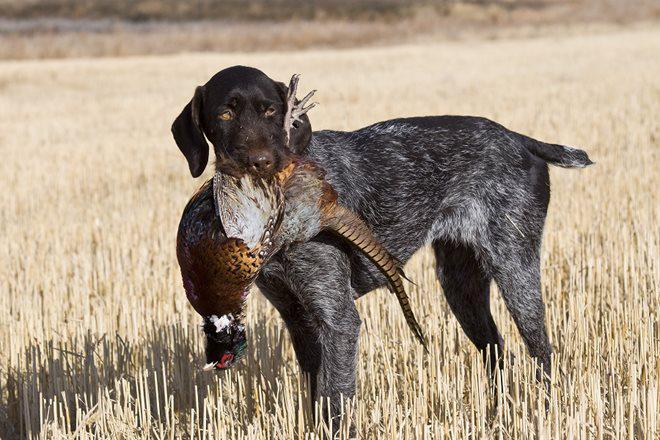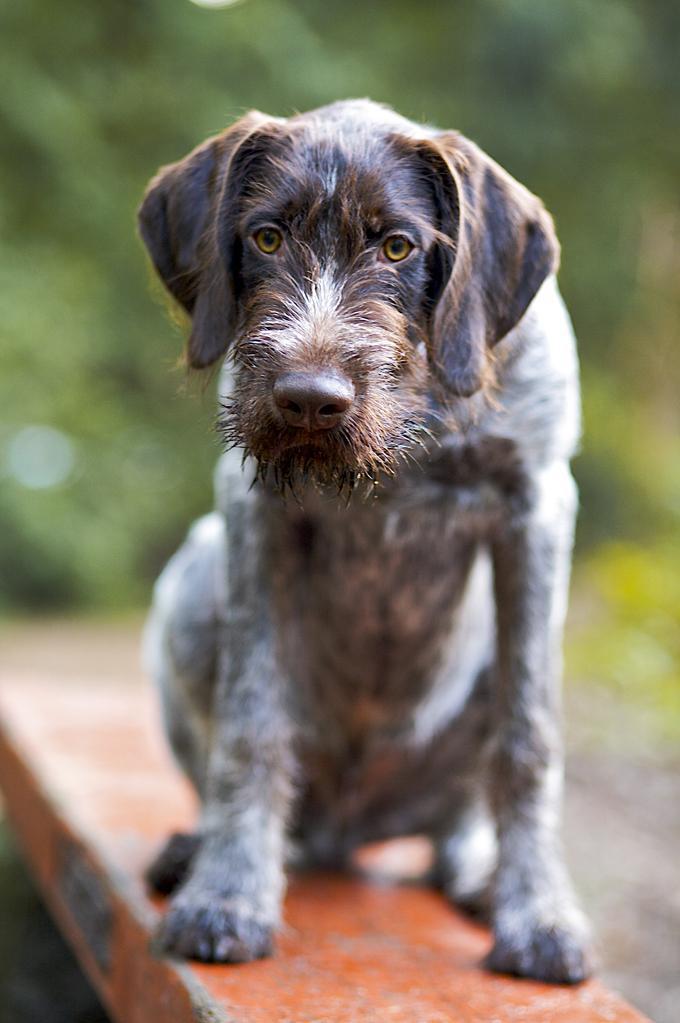The first image is the image on the left, the second image is the image on the right. Evaluate the accuracy of this statement regarding the images: "The right image features a dog on something elevated, and the left image includes a dog and at least one dead game bird.". Is it true? Answer yes or no. Yes. The first image is the image on the left, the second image is the image on the right. Examine the images to the left and right. Is the description "A dog is sitting in the right image." accurate? Answer yes or no. Yes. 